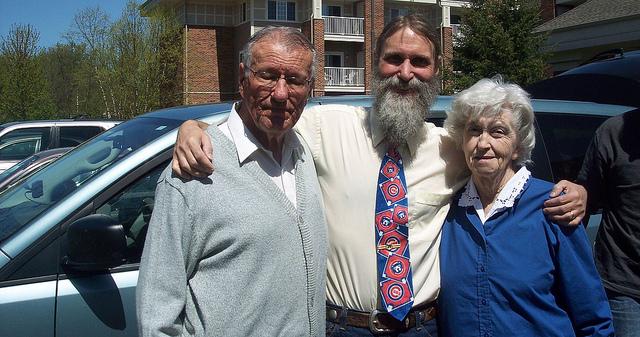Is one of them a woman?
Answer briefly. Yes. Are the men wearing suits?
Short answer required. No. Are the all wearing similar outfits?
Short answer required. No. How many people are wearing a tie?
Quick response, please. 1. How many people have beards?
Answer briefly. 1. What does the man have on his shoulder?
Be succinct. Hand. Who is the shortest?
Give a very brief answer. Woman. 